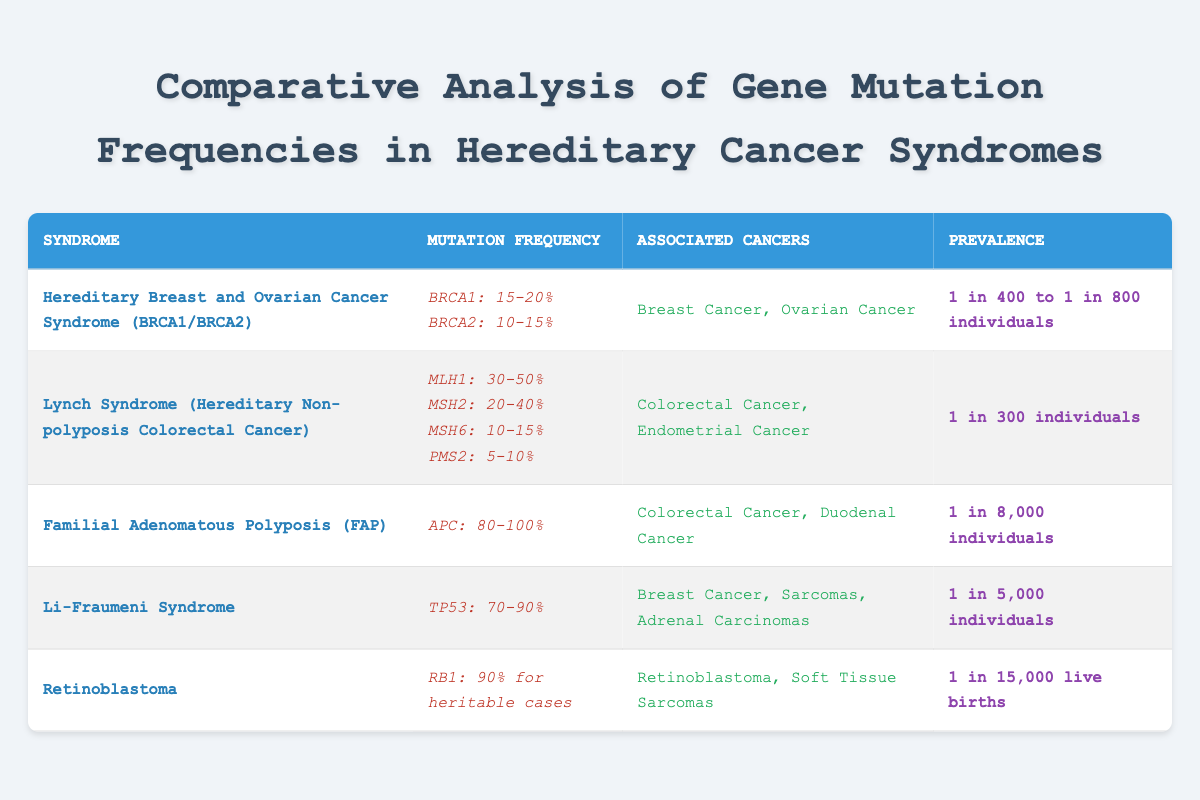What is the mutation frequency of BRCA1? The table lists the mutation frequency for BRCA1 under the "Hereditary Breast and Ovarian Cancer Syndrome" row, which states that the frequency is "15-20%".
Answer: 15-20% Which syndrome has the highest mutation frequency? By reviewing the table, "Familial Adenomatous Polyposis (FAP)" has an APC mutation frequency of "80-100%", which is the highest compared to others.
Answer: Familial Adenomatous Polyposis (FAP) Is the prevalence of Lynch Syndrome higher than that of Li-Fraumeni Syndrome? The prevalence of Lynch Syndrome is "1 in 300 individuals" and the prevalence for Li-Fraumeni Syndrome is "1 in 5,000 individuals". Since 1 in 300 is a larger number, that is a higher prevalence.
Answer: Yes If we average the mutation frequency of the mutations in Lynch Syndrome, what is the approximate value? The mutation frequencies for Lynch Syndrome are MLH1: 30-50%, MSH2: 20-40%, MSH6: 10-15%, and PMS2: 5-10%. To approximate averaging, we take the midpoints: (35 + 30 + 12.5 + 7.5) / 4 ≈ 21.25%.
Answer: 21.25% How many types of cancers are associated with Li-Fraumeni Syndrome? The table indicates that Li-Fraumeni Syndrome is associated with three types of cancers: Breast Cancer, Sarcomas, and Adrenal Carcinomas. Counting these gives a total of three.
Answer: 3 Is it true that all hereditary cancer syndromes listed have a prevalence of 1 in 1,000 or less? By checking the prevalence listed, Lynch Syndrome is "1 in 300", Li-Fraumeni is "1 in 5,000", and Familial Adenomatous Polyposis is "1 in 8,000", which exceeds 1 in 1,000. Therefore, it is not true.
Answer: No What is the difference in the prevalence of Retinoblastoma and FAP? Retinoblastoma has a prevalence of "1 in 15,000 live births" and FAP has "1 in 8,000 individuals". To find the difference in prevalence, we convert both to a common format: 1 in 15,000 is lower than 1 in 8,000, indicating that FAP's prevalence is more common.
Answer: 1 in 8,000 > 1 in 15,000 What percentage of mutation frequency does MSH6 indicate in Lynch Syndrome? The table shows that for Lynch Syndrome, MSH6 has a mutation frequency of "10-15%".
Answer: 10-15% 